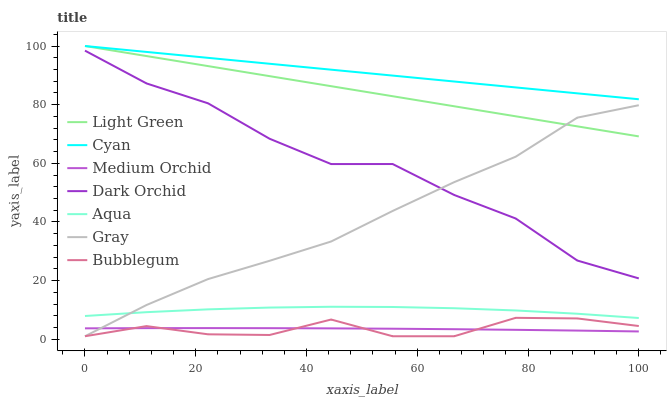Does Medium Orchid have the minimum area under the curve?
Answer yes or no. Yes. Does Cyan have the maximum area under the curve?
Answer yes or no. Yes. Does Aqua have the minimum area under the curve?
Answer yes or no. No. Does Aqua have the maximum area under the curve?
Answer yes or no. No. Is Light Green the smoothest?
Answer yes or no. Yes. Is Dark Orchid the roughest?
Answer yes or no. Yes. Is Medium Orchid the smoothest?
Answer yes or no. No. Is Medium Orchid the roughest?
Answer yes or no. No. Does Gray have the lowest value?
Answer yes or no. Yes. Does Medium Orchid have the lowest value?
Answer yes or no. No. Does Cyan have the highest value?
Answer yes or no. Yes. Does Aqua have the highest value?
Answer yes or no. No. Is Medium Orchid less than Light Green?
Answer yes or no. Yes. Is Aqua greater than Bubblegum?
Answer yes or no. Yes. Does Gray intersect Medium Orchid?
Answer yes or no. Yes. Is Gray less than Medium Orchid?
Answer yes or no. No. Is Gray greater than Medium Orchid?
Answer yes or no. No. Does Medium Orchid intersect Light Green?
Answer yes or no. No. 